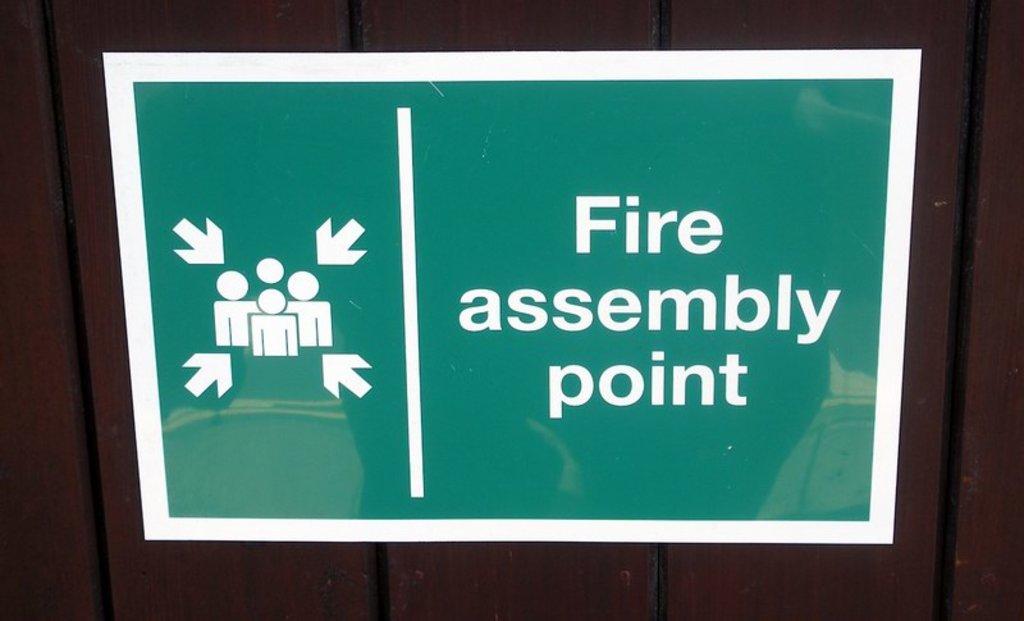What kind of assembly point?
Ensure brevity in your answer.  Fire. What does the sign say?
Keep it short and to the point. Fire assembly point. 